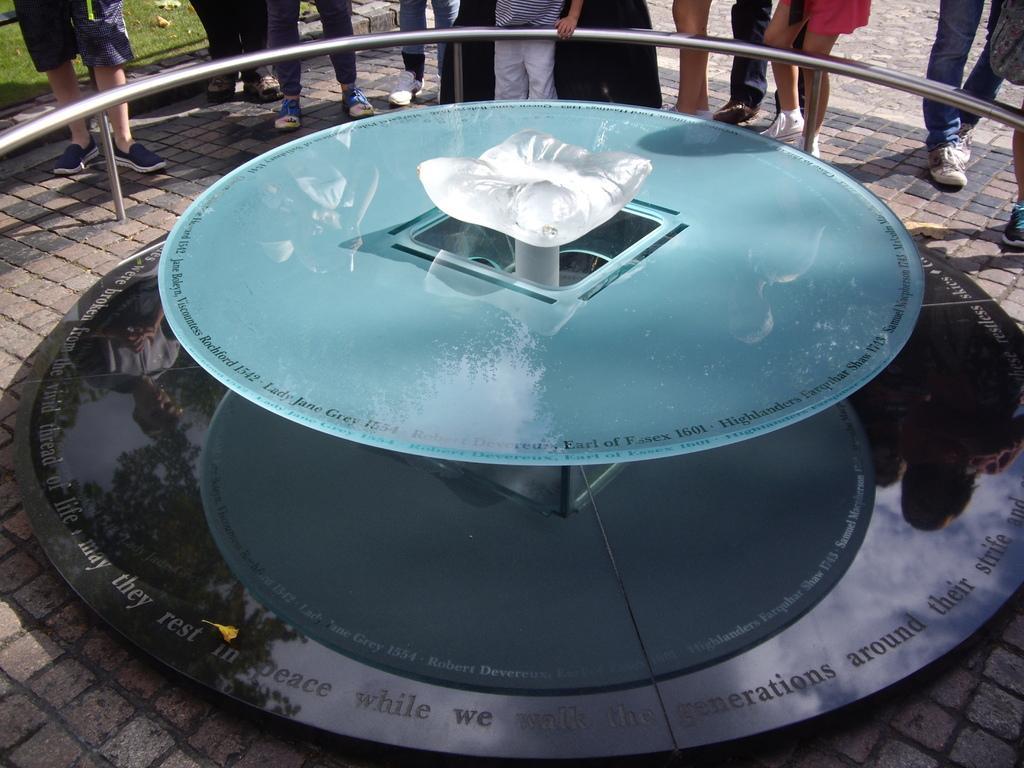Can you describe this image briefly? In this image we can see the legs of a few people, there is a fencing, also we can see an object in the middle of the pavement, also we can see the grass, and the text on the object. 